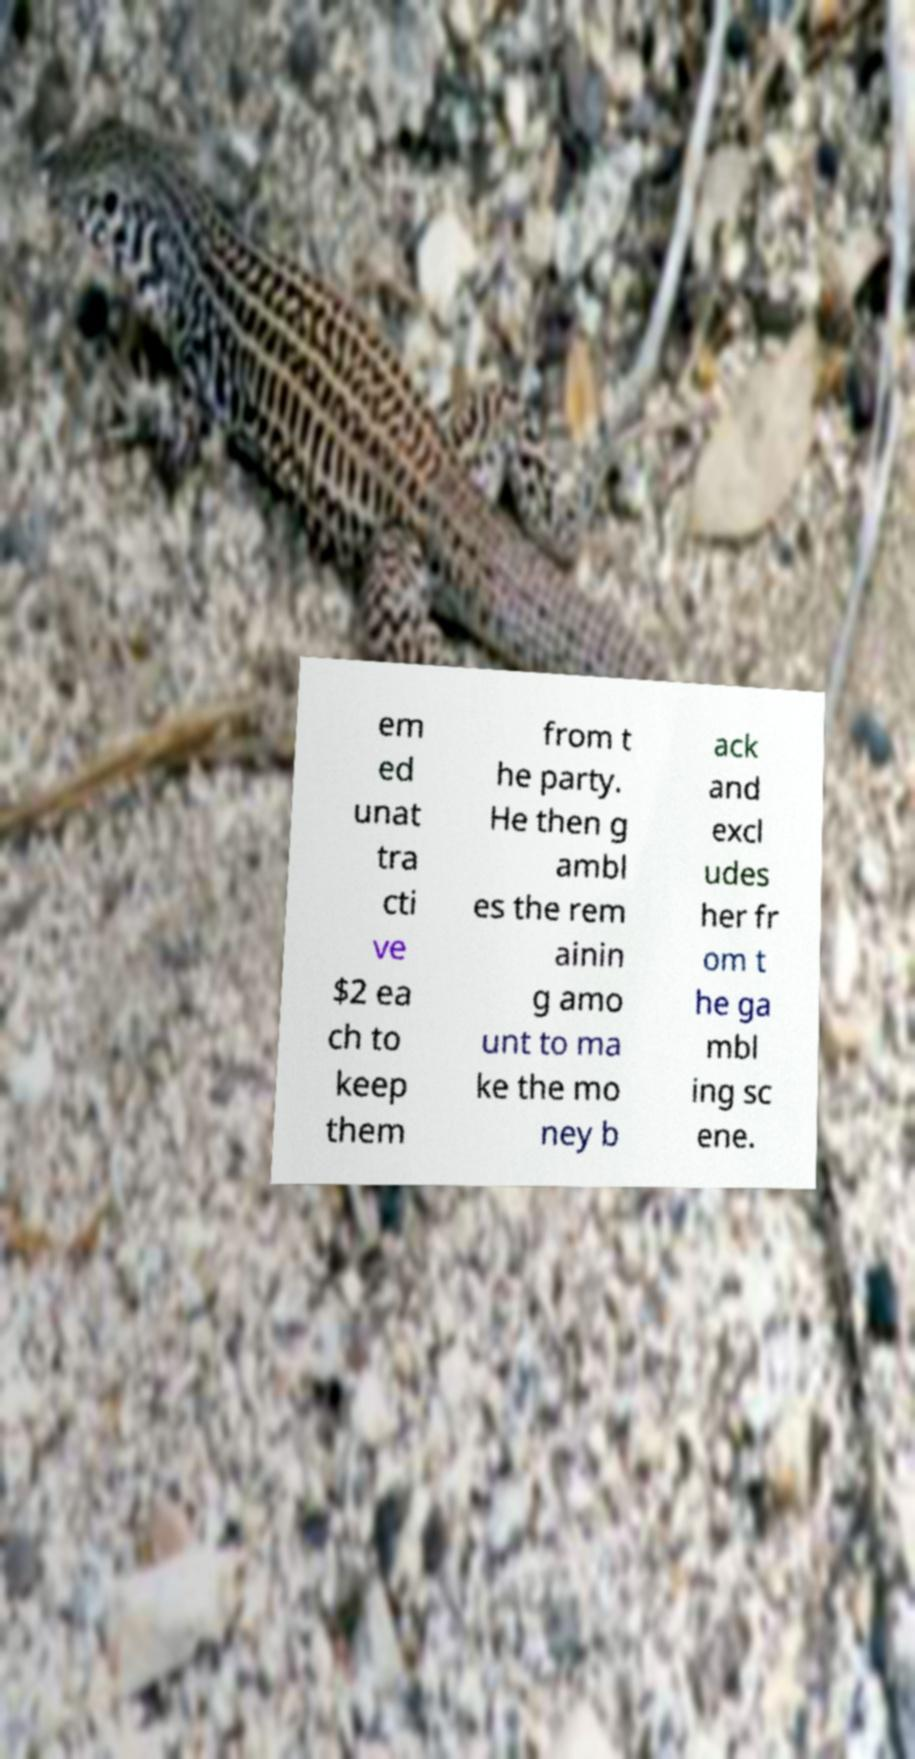Could you extract and type out the text from this image? em ed unat tra cti ve $2 ea ch to keep them from t he party. He then g ambl es the rem ainin g amo unt to ma ke the mo ney b ack and excl udes her fr om t he ga mbl ing sc ene. 